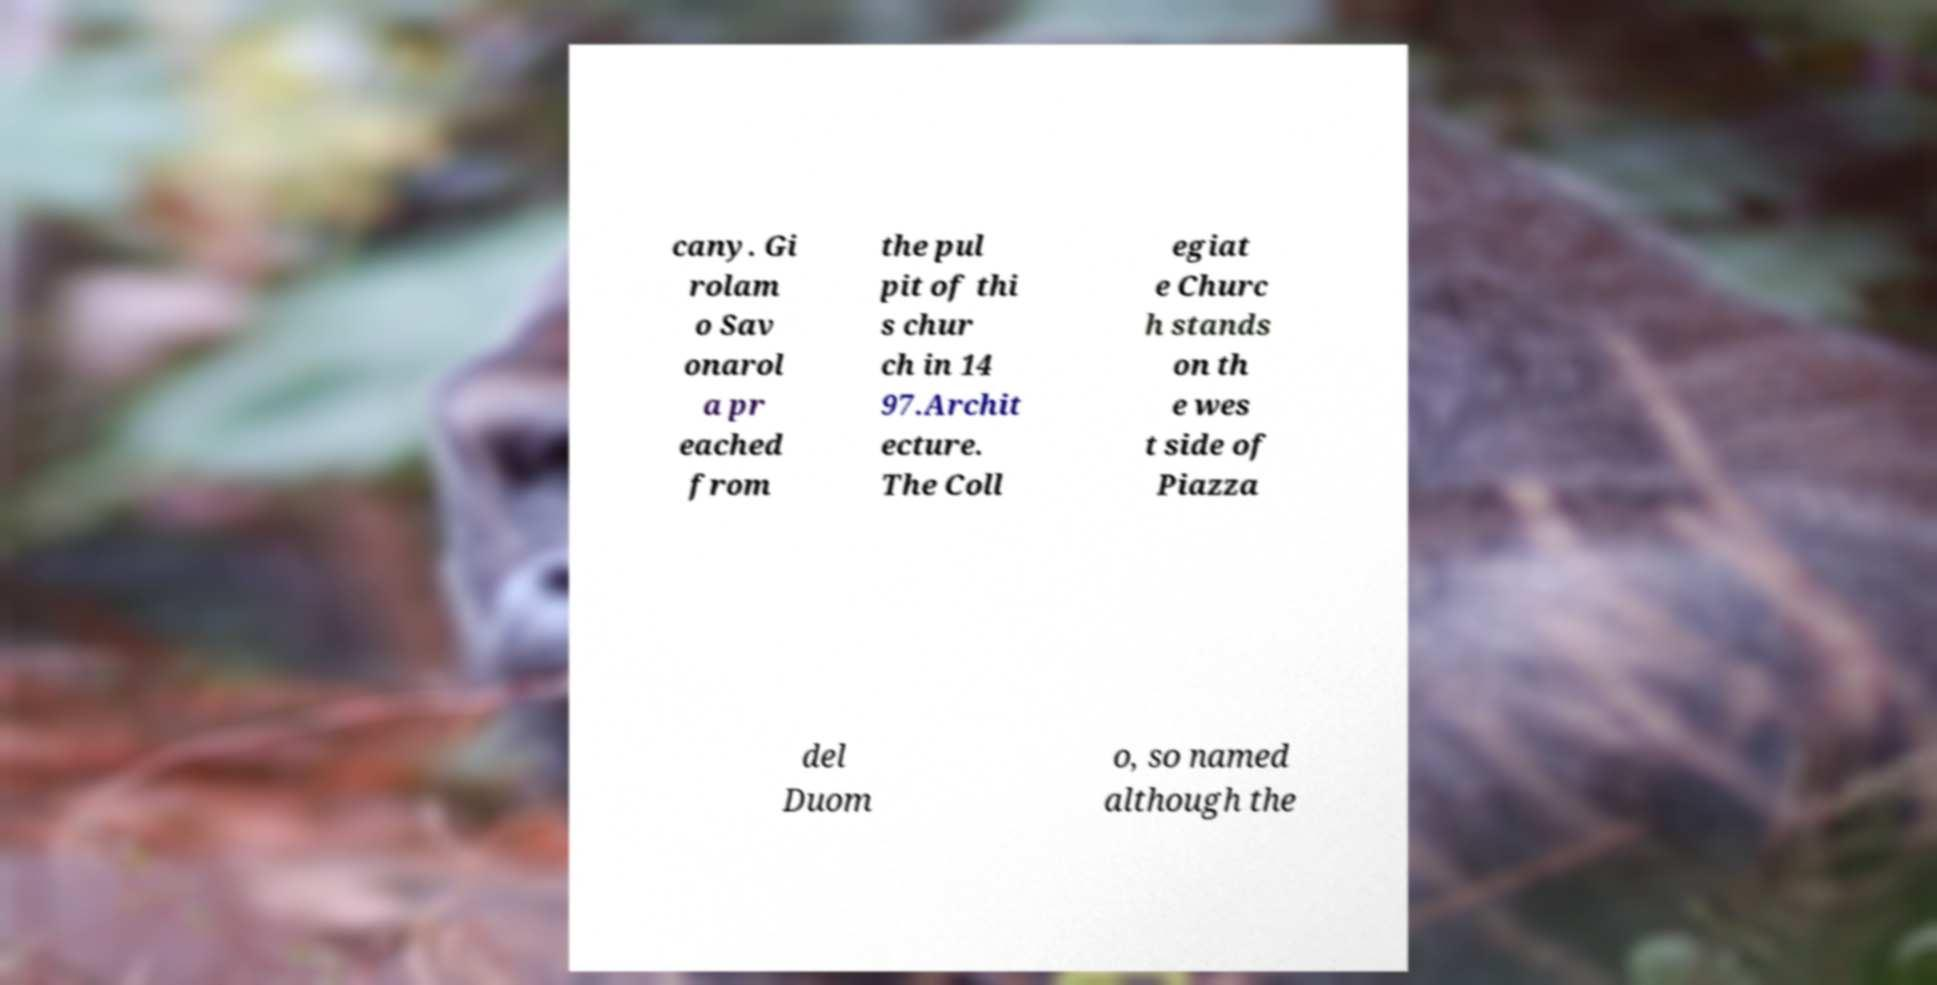Can you accurately transcribe the text from the provided image for me? cany. Gi rolam o Sav onarol a pr eached from the pul pit of thi s chur ch in 14 97.Archit ecture. The Coll egiat e Churc h stands on th e wes t side of Piazza del Duom o, so named although the 